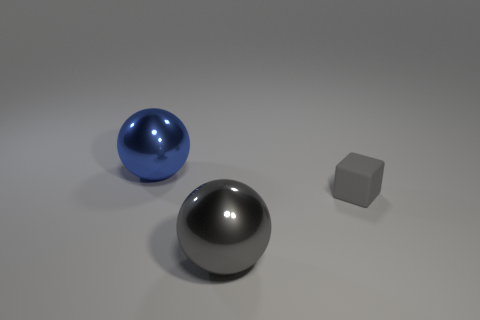There is a shiny ball that is in front of the small gray rubber thing; does it have the same color as the small cube?
Make the answer very short. Yes. Is the gray ball made of the same material as the ball behind the small rubber thing?
Your answer should be compact. Yes. What is the shape of the gray thing behind the gray metallic thing?
Provide a succinct answer. Cube. What number of other objects are there of the same material as the tiny gray cube?
Your answer should be very brief. 0. The blue metallic sphere is what size?
Offer a very short reply. Large. There is a thing that is behind the gray metallic thing and to the left of the tiny object; what is its color?
Offer a terse response. Blue. How many large blue spheres are there?
Your answer should be compact. 1. Are the tiny block and the big blue sphere made of the same material?
Provide a short and direct response. No. There is a large object that is to the left of the metal thing that is on the right side of the shiny ball that is behind the gray block; what is its shape?
Make the answer very short. Sphere. Is the material of the object that is behind the small rubber object the same as the large object that is in front of the small block?
Keep it short and to the point. Yes. 